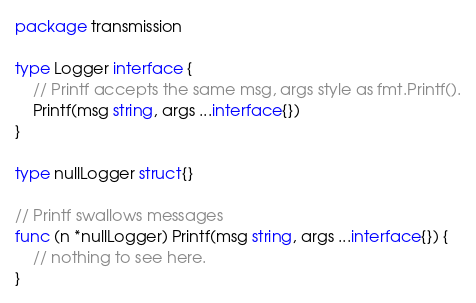<code> <loc_0><loc_0><loc_500><loc_500><_Go_>package transmission

type Logger interface {
	// Printf accepts the same msg, args style as fmt.Printf().
	Printf(msg string, args ...interface{})
}

type nullLogger struct{}

// Printf swallows messages
func (n *nullLogger) Printf(msg string, args ...interface{}) {
	// nothing to see here.
}
</code> 